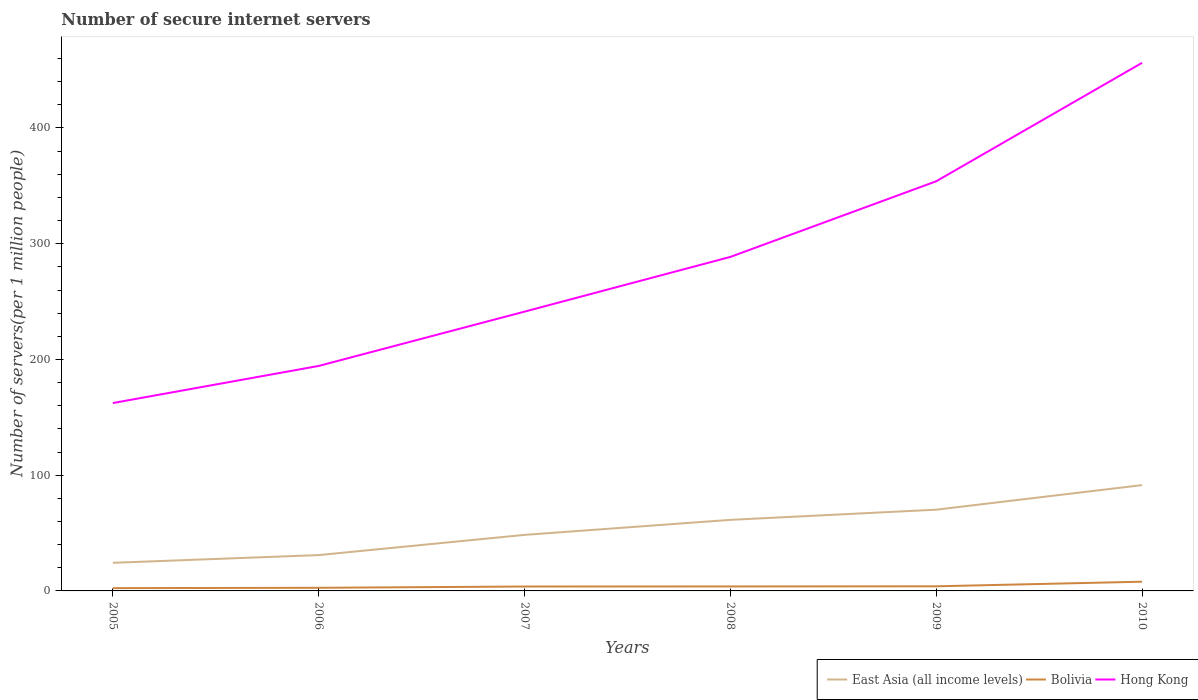Does the line corresponding to Hong Kong intersect with the line corresponding to Bolivia?
Provide a short and direct response. No. Is the number of lines equal to the number of legend labels?
Offer a very short reply. Yes. Across all years, what is the maximum number of secure internet servers in East Asia (all income levels)?
Give a very brief answer. 24.29. What is the total number of secure internet servers in East Asia (all income levels) in the graph?
Ensure brevity in your answer.  -6.67. What is the difference between the highest and the second highest number of secure internet servers in Hong Kong?
Keep it short and to the point. 293.95. What is the difference between two consecutive major ticks on the Y-axis?
Keep it short and to the point. 100. Are the values on the major ticks of Y-axis written in scientific E-notation?
Offer a very short reply. No. Does the graph contain grids?
Keep it short and to the point. No. Where does the legend appear in the graph?
Offer a terse response. Bottom right. What is the title of the graph?
Keep it short and to the point. Number of secure internet servers. What is the label or title of the Y-axis?
Offer a very short reply. Number of servers(per 1 million people). What is the Number of servers(per 1 million people) in East Asia (all income levels) in 2005?
Your answer should be compact. 24.29. What is the Number of servers(per 1 million people) in Bolivia in 2005?
Provide a short and direct response. 2.41. What is the Number of servers(per 1 million people) in Hong Kong in 2005?
Offer a terse response. 162.33. What is the Number of servers(per 1 million people) of East Asia (all income levels) in 2006?
Your answer should be compact. 30.96. What is the Number of servers(per 1 million people) in Bolivia in 2006?
Offer a very short reply. 2.69. What is the Number of servers(per 1 million people) of Hong Kong in 2006?
Keep it short and to the point. 194.4. What is the Number of servers(per 1 million people) of East Asia (all income levels) in 2007?
Keep it short and to the point. 48.42. What is the Number of servers(per 1 million people) of Bolivia in 2007?
Offer a very short reply. 3.81. What is the Number of servers(per 1 million people) of Hong Kong in 2007?
Keep it short and to the point. 241.31. What is the Number of servers(per 1 million people) of East Asia (all income levels) in 2008?
Your response must be concise. 61.4. What is the Number of servers(per 1 million people) in Bolivia in 2008?
Offer a very short reply. 3.85. What is the Number of servers(per 1 million people) of Hong Kong in 2008?
Provide a short and direct response. 288.6. What is the Number of servers(per 1 million people) in East Asia (all income levels) in 2009?
Give a very brief answer. 70.2. What is the Number of servers(per 1 million people) in Bolivia in 2009?
Provide a succinct answer. 4. What is the Number of servers(per 1 million people) in Hong Kong in 2009?
Offer a very short reply. 353.95. What is the Number of servers(per 1 million people) of East Asia (all income levels) in 2010?
Provide a succinct answer. 91.42. What is the Number of servers(per 1 million people) of Bolivia in 2010?
Ensure brevity in your answer.  7.97. What is the Number of servers(per 1 million people) in Hong Kong in 2010?
Your answer should be very brief. 456.28. Across all years, what is the maximum Number of servers(per 1 million people) of East Asia (all income levels)?
Give a very brief answer. 91.42. Across all years, what is the maximum Number of servers(per 1 million people) in Bolivia?
Your answer should be compact. 7.97. Across all years, what is the maximum Number of servers(per 1 million people) of Hong Kong?
Offer a terse response. 456.28. Across all years, what is the minimum Number of servers(per 1 million people) in East Asia (all income levels)?
Offer a very short reply. 24.29. Across all years, what is the minimum Number of servers(per 1 million people) in Bolivia?
Your response must be concise. 2.41. Across all years, what is the minimum Number of servers(per 1 million people) in Hong Kong?
Keep it short and to the point. 162.33. What is the total Number of servers(per 1 million people) of East Asia (all income levels) in the graph?
Give a very brief answer. 326.7. What is the total Number of servers(per 1 million people) in Bolivia in the graph?
Give a very brief answer. 24.73. What is the total Number of servers(per 1 million people) of Hong Kong in the graph?
Your response must be concise. 1696.87. What is the difference between the Number of servers(per 1 million people) of East Asia (all income levels) in 2005 and that in 2006?
Make the answer very short. -6.67. What is the difference between the Number of servers(per 1 million people) of Bolivia in 2005 and that in 2006?
Your answer should be very brief. -0.28. What is the difference between the Number of servers(per 1 million people) in Hong Kong in 2005 and that in 2006?
Offer a very short reply. -32.07. What is the difference between the Number of servers(per 1 million people) in East Asia (all income levels) in 2005 and that in 2007?
Ensure brevity in your answer.  -24.13. What is the difference between the Number of servers(per 1 million people) of Bolivia in 2005 and that in 2007?
Offer a very short reply. -1.4. What is the difference between the Number of servers(per 1 million people) in Hong Kong in 2005 and that in 2007?
Your response must be concise. -78.98. What is the difference between the Number of servers(per 1 million people) of East Asia (all income levels) in 2005 and that in 2008?
Your answer should be compact. -37.11. What is the difference between the Number of servers(per 1 million people) in Bolivia in 2005 and that in 2008?
Give a very brief answer. -1.44. What is the difference between the Number of servers(per 1 million people) in Hong Kong in 2005 and that in 2008?
Provide a succinct answer. -126.27. What is the difference between the Number of servers(per 1 million people) in East Asia (all income levels) in 2005 and that in 2009?
Keep it short and to the point. -45.91. What is the difference between the Number of servers(per 1 million people) of Bolivia in 2005 and that in 2009?
Your response must be concise. -1.59. What is the difference between the Number of servers(per 1 million people) in Hong Kong in 2005 and that in 2009?
Ensure brevity in your answer.  -191.61. What is the difference between the Number of servers(per 1 million people) of East Asia (all income levels) in 2005 and that in 2010?
Provide a succinct answer. -67.13. What is the difference between the Number of servers(per 1 million people) of Bolivia in 2005 and that in 2010?
Your answer should be compact. -5.55. What is the difference between the Number of servers(per 1 million people) in Hong Kong in 2005 and that in 2010?
Make the answer very short. -293.95. What is the difference between the Number of servers(per 1 million people) of East Asia (all income levels) in 2006 and that in 2007?
Your response must be concise. -17.46. What is the difference between the Number of servers(per 1 million people) in Bolivia in 2006 and that in 2007?
Offer a very short reply. -1.12. What is the difference between the Number of servers(per 1 million people) of Hong Kong in 2006 and that in 2007?
Your answer should be compact. -46.92. What is the difference between the Number of servers(per 1 million people) in East Asia (all income levels) in 2006 and that in 2008?
Your answer should be compact. -30.44. What is the difference between the Number of servers(per 1 million people) in Bolivia in 2006 and that in 2008?
Make the answer very short. -1.16. What is the difference between the Number of servers(per 1 million people) in Hong Kong in 2006 and that in 2008?
Offer a terse response. -94.2. What is the difference between the Number of servers(per 1 million people) in East Asia (all income levels) in 2006 and that in 2009?
Provide a short and direct response. -39.24. What is the difference between the Number of servers(per 1 million people) in Bolivia in 2006 and that in 2009?
Offer a very short reply. -1.3. What is the difference between the Number of servers(per 1 million people) in Hong Kong in 2006 and that in 2009?
Provide a short and direct response. -159.55. What is the difference between the Number of servers(per 1 million people) in East Asia (all income levels) in 2006 and that in 2010?
Ensure brevity in your answer.  -60.46. What is the difference between the Number of servers(per 1 million people) of Bolivia in 2006 and that in 2010?
Your answer should be very brief. -5.27. What is the difference between the Number of servers(per 1 million people) of Hong Kong in 2006 and that in 2010?
Ensure brevity in your answer.  -261.88. What is the difference between the Number of servers(per 1 million people) in East Asia (all income levels) in 2007 and that in 2008?
Ensure brevity in your answer.  -12.98. What is the difference between the Number of servers(per 1 million people) of Bolivia in 2007 and that in 2008?
Provide a succinct answer. -0.04. What is the difference between the Number of servers(per 1 million people) in Hong Kong in 2007 and that in 2008?
Make the answer very short. -47.28. What is the difference between the Number of servers(per 1 million people) of East Asia (all income levels) in 2007 and that in 2009?
Make the answer very short. -21.78. What is the difference between the Number of servers(per 1 million people) in Bolivia in 2007 and that in 2009?
Your response must be concise. -0.18. What is the difference between the Number of servers(per 1 million people) in Hong Kong in 2007 and that in 2009?
Keep it short and to the point. -112.63. What is the difference between the Number of servers(per 1 million people) in East Asia (all income levels) in 2007 and that in 2010?
Keep it short and to the point. -43.01. What is the difference between the Number of servers(per 1 million people) in Bolivia in 2007 and that in 2010?
Give a very brief answer. -4.15. What is the difference between the Number of servers(per 1 million people) in Hong Kong in 2007 and that in 2010?
Your response must be concise. -214.97. What is the difference between the Number of servers(per 1 million people) of East Asia (all income levels) in 2008 and that in 2009?
Provide a succinct answer. -8.8. What is the difference between the Number of servers(per 1 million people) of Bolivia in 2008 and that in 2009?
Provide a succinct answer. -0.14. What is the difference between the Number of servers(per 1 million people) in Hong Kong in 2008 and that in 2009?
Your response must be concise. -65.35. What is the difference between the Number of servers(per 1 million people) in East Asia (all income levels) in 2008 and that in 2010?
Your response must be concise. -30.02. What is the difference between the Number of servers(per 1 million people) of Bolivia in 2008 and that in 2010?
Offer a very short reply. -4.11. What is the difference between the Number of servers(per 1 million people) in Hong Kong in 2008 and that in 2010?
Your answer should be compact. -167.68. What is the difference between the Number of servers(per 1 million people) of East Asia (all income levels) in 2009 and that in 2010?
Offer a terse response. -21.22. What is the difference between the Number of servers(per 1 million people) of Bolivia in 2009 and that in 2010?
Give a very brief answer. -3.97. What is the difference between the Number of servers(per 1 million people) in Hong Kong in 2009 and that in 2010?
Your response must be concise. -102.33. What is the difference between the Number of servers(per 1 million people) of East Asia (all income levels) in 2005 and the Number of servers(per 1 million people) of Bolivia in 2006?
Offer a very short reply. 21.6. What is the difference between the Number of servers(per 1 million people) in East Asia (all income levels) in 2005 and the Number of servers(per 1 million people) in Hong Kong in 2006?
Offer a very short reply. -170.11. What is the difference between the Number of servers(per 1 million people) in Bolivia in 2005 and the Number of servers(per 1 million people) in Hong Kong in 2006?
Provide a short and direct response. -191.99. What is the difference between the Number of servers(per 1 million people) in East Asia (all income levels) in 2005 and the Number of servers(per 1 million people) in Bolivia in 2007?
Provide a short and direct response. 20.48. What is the difference between the Number of servers(per 1 million people) of East Asia (all income levels) in 2005 and the Number of servers(per 1 million people) of Hong Kong in 2007?
Provide a short and direct response. -217.02. What is the difference between the Number of servers(per 1 million people) of Bolivia in 2005 and the Number of servers(per 1 million people) of Hong Kong in 2007?
Ensure brevity in your answer.  -238.9. What is the difference between the Number of servers(per 1 million people) of East Asia (all income levels) in 2005 and the Number of servers(per 1 million people) of Bolivia in 2008?
Offer a very short reply. 20.44. What is the difference between the Number of servers(per 1 million people) of East Asia (all income levels) in 2005 and the Number of servers(per 1 million people) of Hong Kong in 2008?
Provide a short and direct response. -264.31. What is the difference between the Number of servers(per 1 million people) of Bolivia in 2005 and the Number of servers(per 1 million people) of Hong Kong in 2008?
Your answer should be very brief. -286.19. What is the difference between the Number of servers(per 1 million people) of East Asia (all income levels) in 2005 and the Number of servers(per 1 million people) of Bolivia in 2009?
Offer a very short reply. 20.29. What is the difference between the Number of servers(per 1 million people) of East Asia (all income levels) in 2005 and the Number of servers(per 1 million people) of Hong Kong in 2009?
Your answer should be compact. -329.66. What is the difference between the Number of servers(per 1 million people) of Bolivia in 2005 and the Number of servers(per 1 million people) of Hong Kong in 2009?
Your answer should be very brief. -351.54. What is the difference between the Number of servers(per 1 million people) of East Asia (all income levels) in 2005 and the Number of servers(per 1 million people) of Bolivia in 2010?
Give a very brief answer. 16.33. What is the difference between the Number of servers(per 1 million people) of East Asia (all income levels) in 2005 and the Number of servers(per 1 million people) of Hong Kong in 2010?
Your answer should be very brief. -431.99. What is the difference between the Number of servers(per 1 million people) in Bolivia in 2005 and the Number of servers(per 1 million people) in Hong Kong in 2010?
Offer a terse response. -453.87. What is the difference between the Number of servers(per 1 million people) in East Asia (all income levels) in 2006 and the Number of servers(per 1 million people) in Bolivia in 2007?
Provide a short and direct response. 27.15. What is the difference between the Number of servers(per 1 million people) in East Asia (all income levels) in 2006 and the Number of servers(per 1 million people) in Hong Kong in 2007?
Ensure brevity in your answer.  -210.35. What is the difference between the Number of servers(per 1 million people) in Bolivia in 2006 and the Number of servers(per 1 million people) in Hong Kong in 2007?
Provide a short and direct response. -238.62. What is the difference between the Number of servers(per 1 million people) in East Asia (all income levels) in 2006 and the Number of servers(per 1 million people) in Bolivia in 2008?
Ensure brevity in your answer.  27.11. What is the difference between the Number of servers(per 1 million people) in East Asia (all income levels) in 2006 and the Number of servers(per 1 million people) in Hong Kong in 2008?
Your answer should be compact. -257.63. What is the difference between the Number of servers(per 1 million people) of Bolivia in 2006 and the Number of servers(per 1 million people) of Hong Kong in 2008?
Provide a short and direct response. -285.9. What is the difference between the Number of servers(per 1 million people) in East Asia (all income levels) in 2006 and the Number of servers(per 1 million people) in Bolivia in 2009?
Offer a terse response. 26.97. What is the difference between the Number of servers(per 1 million people) of East Asia (all income levels) in 2006 and the Number of servers(per 1 million people) of Hong Kong in 2009?
Offer a very short reply. -322.98. What is the difference between the Number of servers(per 1 million people) in Bolivia in 2006 and the Number of servers(per 1 million people) in Hong Kong in 2009?
Your answer should be compact. -351.25. What is the difference between the Number of servers(per 1 million people) in East Asia (all income levels) in 2006 and the Number of servers(per 1 million people) in Bolivia in 2010?
Your answer should be very brief. 23. What is the difference between the Number of servers(per 1 million people) of East Asia (all income levels) in 2006 and the Number of servers(per 1 million people) of Hong Kong in 2010?
Ensure brevity in your answer.  -425.32. What is the difference between the Number of servers(per 1 million people) in Bolivia in 2006 and the Number of servers(per 1 million people) in Hong Kong in 2010?
Keep it short and to the point. -453.59. What is the difference between the Number of servers(per 1 million people) in East Asia (all income levels) in 2007 and the Number of servers(per 1 million people) in Bolivia in 2008?
Your answer should be compact. 44.56. What is the difference between the Number of servers(per 1 million people) in East Asia (all income levels) in 2007 and the Number of servers(per 1 million people) in Hong Kong in 2008?
Your response must be concise. -240.18. What is the difference between the Number of servers(per 1 million people) in Bolivia in 2007 and the Number of servers(per 1 million people) in Hong Kong in 2008?
Ensure brevity in your answer.  -284.78. What is the difference between the Number of servers(per 1 million people) in East Asia (all income levels) in 2007 and the Number of servers(per 1 million people) in Bolivia in 2009?
Your answer should be compact. 44.42. What is the difference between the Number of servers(per 1 million people) of East Asia (all income levels) in 2007 and the Number of servers(per 1 million people) of Hong Kong in 2009?
Offer a very short reply. -305.53. What is the difference between the Number of servers(per 1 million people) in Bolivia in 2007 and the Number of servers(per 1 million people) in Hong Kong in 2009?
Make the answer very short. -350.13. What is the difference between the Number of servers(per 1 million people) of East Asia (all income levels) in 2007 and the Number of servers(per 1 million people) of Bolivia in 2010?
Your answer should be very brief. 40.45. What is the difference between the Number of servers(per 1 million people) in East Asia (all income levels) in 2007 and the Number of servers(per 1 million people) in Hong Kong in 2010?
Make the answer very short. -407.86. What is the difference between the Number of servers(per 1 million people) in Bolivia in 2007 and the Number of servers(per 1 million people) in Hong Kong in 2010?
Offer a very short reply. -452.47. What is the difference between the Number of servers(per 1 million people) in East Asia (all income levels) in 2008 and the Number of servers(per 1 million people) in Bolivia in 2009?
Provide a succinct answer. 57.4. What is the difference between the Number of servers(per 1 million people) of East Asia (all income levels) in 2008 and the Number of servers(per 1 million people) of Hong Kong in 2009?
Keep it short and to the point. -292.55. What is the difference between the Number of servers(per 1 million people) of Bolivia in 2008 and the Number of servers(per 1 million people) of Hong Kong in 2009?
Offer a very short reply. -350.09. What is the difference between the Number of servers(per 1 million people) of East Asia (all income levels) in 2008 and the Number of servers(per 1 million people) of Bolivia in 2010?
Give a very brief answer. 53.43. What is the difference between the Number of servers(per 1 million people) in East Asia (all income levels) in 2008 and the Number of servers(per 1 million people) in Hong Kong in 2010?
Give a very brief answer. -394.88. What is the difference between the Number of servers(per 1 million people) of Bolivia in 2008 and the Number of servers(per 1 million people) of Hong Kong in 2010?
Make the answer very short. -452.43. What is the difference between the Number of servers(per 1 million people) of East Asia (all income levels) in 2009 and the Number of servers(per 1 million people) of Bolivia in 2010?
Your answer should be very brief. 62.24. What is the difference between the Number of servers(per 1 million people) of East Asia (all income levels) in 2009 and the Number of servers(per 1 million people) of Hong Kong in 2010?
Make the answer very short. -386.08. What is the difference between the Number of servers(per 1 million people) in Bolivia in 2009 and the Number of servers(per 1 million people) in Hong Kong in 2010?
Keep it short and to the point. -452.28. What is the average Number of servers(per 1 million people) in East Asia (all income levels) per year?
Your response must be concise. 54.45. What is the average Number of servers(per 1 million people) in Bolivia per year?
Your response must be concise. 4.12. What is the average Number of servers(per 1 million people) in Hong Kong per year?
Your response must be concise. 282.81. In the year 2005, what is the difference between the Number of servers(per 1 million people) of East Asia (all income levels) and Number of servers(per 1 million people) of Bolivia?
Offer a terse response. 21.88. In the year 2005, what is the difference between the Number of servers(per 1 million people) in East Asia (all income levels) and Number of servers(per 1 million people) in Hong Kong?
Your answer should be very brief. -138.04. In the year 2005, what is the difference between the Number of servers(per 1 million people) in Bolivia and Number of servers(per 1 million people) in Hong Kong?
Keep it short and to the point. -159.92. In the year 2006, what is the difference between the Number of servers(per 1 million people) in East Asia (all income levels) and Number of servers(per 1 million people) in Bolivia?
Offer a terse response. 28.27. In the year 2006, what is the difference between the Number of servers(per 1 million people) in East Asia (all income levels) and Number of servers(per 1 million people) in Hong Kong?
Ensure brevity in your answer.  -163.43. In the year 2006, what is the difference between the Number of servers(per 1 million people) of Bolivia and Number of servers(per 1 million people) of Hong Kong?
Offer a very short reply. -191.7. In the year 2007, what is the difference between the Number of servers(per 1 million people) of East Asia (all income levels) and Number of servers(per 1 million people) of Bolivia?
Your answer should be very brief. 44.61. In the year 2007, what is the difference between the Number of servers(per 1 million people) in East Asia (all income levels) and Number of servers(per 1 million people) in Hong Kong?
Provide a short and direct response. -192.89. In the year 2007, what is the difference between the Number of servers(per 1 million people) in Bolivia and Number of servers(per 1 million people) in Hong Kong?
Your answer should be compact. -237.5. In the year 2008, what is the difference between the Number of servers(per 1 million people) of East Asia (all income levels) and Number of servers(per 1 million people) of Bolivia?
Your answer should be very brief. 57.55. In the year 2008, what is the difference between the Number of servers(per 1 million people) of East Asia (all income levels) and Number of servers(per 1 million people) of Hong Kong?
Offer a terse response. -227.2. In the year 2008, what is the difference between the Number of servers(per 1 million people) in Bolivia and Number of servers(per 1 million people) in Hong Kong?
Make the answer very short. -284.74. In the year 2009, what is the difference between the Number of servers(per 1 million people) of East Asia (all income levels) and Number of servers(per 1 million people) of Bolivia?
Offer a very short reply. 66.2. In the year 2009, what is the difference between the Number of servers(per 1 million people) in East Asia (all income levels) and Number of servers(per 1 million people) in Hong Kong?
Offer a very short reply. -283.75. In the year 2009, what is the difference between the Number of servers(per 1 million people) in Bolivia and Number of servers(per 1 million people) in Hong Kong?
Give a very brief answer. -349.95. In the year 2010, what is the difference between the Number of servers(per 1 million people) of East Asia (all income levels) and Number of servers(per 1 million people) of Bolivia?
Ensure brevity in your answer.  83.46. In the year 2010, what is the difference between the Number of servers(per 1 million people) of East Asia (all income levels) and Number of servers(per 1 million people) of Hong Kong?
Offer a very short reply. -364.86. In the year 2010, what is the difference between the Number of servers(per 1 million people) in Bolivia and Number of servers(per 1 million people) in Hong Kong?
Keep it short and to the point. -448.31. What is the ratio of the Number of servers(per 1 million people) in East Asia (all income levels) in 2005 to that in 2006?
Offer a very short reply. 0.78. What is the ratio of the Number of servers(per 1 million people) of Bolivia in 2005 to that in 2006?
Offer a very short reply. 0.9. What is the ratio of the Number of servers(per 1 million people) of Hong Kong in 2005 to that in 2006?
Give a very brief answer. 0.84. What is the ratio of the Number of servers(per 1 million people) of East Asia (all income levels) in 2005 to that in 2007?
Make the answer very short. 0.5. What is the ratio of the Number of servers(per 1 million people) of Bolivia in 2005 to that in 2007?
Your response must be concise. 0.63. What is the ratio of the Number of servers(per 1 million people) of Hong Kong in 2005 to that in 2007?
Provide a short and direct response. 0.67. What is the ratio of the Number of servers(per 1 million people) in East Asia (all income levels) in 2005 to that in 2008?
Your answer should be compact. 0.4. What is the ratio of the Number of servers(per 1 million people) of Bolivia in 2005 to that in 2008?
Ensure brevity in your answer.  0.63. What is the ratio of the Number of servers(per 1 million people) of Hong Kong in 2005 to that in 2008?
Provide a short and direct response. 0.56. What is the ratio of the Number of servers(per 1 million people) in East Asia (all income levels) in 2005 to that in 2009?
Your response must be concise. 0.35. What is the ratio of the Number of servers(per 1 million people) in Bolivia in 2005 to that in 2009?
Make the answer very short. 0.6. What is the ratio of the Number of servers(per 1 million people) in Hong Kong in 2005 to that in 2009?
Your response must be concise. 0.46. What is the ratio of the Number of servers(per 1 million people) in East Asia (all income levels) in 2005 to that in 2010?
Ensure brevity in your answer.  0.27. What is the ratio of the Number of servers(per 1 million people) in Bolivia in 2005 to that in 2010?
Provide a succinct answer. 0.3. What is the ratio of the Number of servers(per 1 million people) of Hong Kong in 2005 to that in 2010?
Keep it short and to the point. 0.36. What is the ratio of the Number of servers(per 1 million people) in East Asia (all income levels) in 2006 to that in 2007?
Keep it short and to the point. 0.64. What is the ratio of the Number of servers(per 1 million people) in Bolivia in 2006 to that in 2007?
Ensure brevity in your answer.  0.71. What is the ratio of the Number of servers(per 1 million people) in Hong Kong in 2006 to that in 2007?
Provide a short and direct response. 0.81. What is the ratio of the Number of servers(per 1 million people) of East Asia (all income levels) in 2006 to that in 2008?
Ensure brevity in your answer.  0.5. What is the ratio of the Number of servers(per 1 million people) of Bolivia in 2006 to that in 2008?
Make the answer very short. 0.7. What is the ratio of the Number of servers(per 1 million people) in Hong Kong in 2006 to that in 2008?
Provide a succinct answer. 0.67. What is the ratio of the Number of servers(per 1 million people) of East Asia (all income levels) in 2006 to that in 2009?
Offer a very short reply. 0.44. What is the ratio of the Number of servers(per 1 million people) in Bolivia in 2006 to that in 2009?
Offer a very short reply. 0.67. What is the ratio of the Number of servers(per 1 million people) in Hong Kong in 2006 to that in 2009?
Provide a succinct answer. 0.55. What is the ratio of the Number of servers(per 1 million people) of East Asia (all income levels) in 2006 to that in 2010?
Provide a succinct answer. 0.34. What is the ratio of the Number of servers(per 1 million people) of Bolivia in 2006 to that in 2010?
Your answer should be very brief. 0.34. What is the ratio of the Number of servers(per 1 million people) of Hong Kong in 2006 to that in 2010?
Offer a terse response. 0.43. What is the ratio of the Number of servers(per 1 million people) of East Asia (all income levels) in 2007 to that in 2008?
Ensure brevity in your answer.  0.79. What is the ratio of the Number of servers(per 1 million people) in Bolivia in 2007 to that in 2008?
Provide a short and direct response. 0.99. What is the ratio of the Number of servers(per 1 million people) in Hong Kong in 2007 to that in 2008?
Give a very brief answer. 0.84. What is the ratio of the Number of servers(per 1 million people) in East Asia (all income levels) in 2007 to that in 2009?
Offer a very short reply. 0.69. What is the ratio of the Number of servers(per 1 million people) in Bolivia in 2007 to that in 2009?
Make the answer very short. 0.95. What is the ratio of the Number of servers(per 1 million people) of Hong Kong in 2007 to that in 2009?
Your answer should be compact. 0.68. What is the ratio of the Number of servers(per 1 million people) in East Asia (all income levels) in 2007 to that in 2010?
Your answer should be compact. 0.53. What is the ratio of the Number of servers(per 1 million people) of Bolivia in 2007 to that in 2010?
Keep it short and to the point. 0.48. What is the ratio of the Number of servers(per 1 million people) in Hong Kong in 2007 to that in 2010?
Keep it short and to the point. 0.53. What is the ratio of the Number of servers(per 1 million people) in East Asia (all income levels) in 2008 to that in 2009?
Your answer should be compact. 0.87. What is the ratio of the Number of servers(per 1 million people) in Bolivia in 2008 to that in 2009?
Provide a short and direct response. 0.96. What is the ratio of the Number of servers(per 1 million people) of Hong Kong in 2008 to that in 2009?
Your response must be concise. 0.82. What is the ratio of the Number of servers(per 1 million people) in East Asia (all income levels) in 2008 to that in 2010?
Offer a terse response. 0.67. What is the ratio of the Number of servers(per 1 million people) of Bolivia in 2008 to that in 2010?
Your answer should be compact. 0.48. What is the ratio of the Number of servers(per 1 million people) of Hong Kong in 2008 to that in 2010?
Your answer should be very brief. 0.63. What is the ratio of the Number of servers(per 1 million people) of East Asia (all income levels) in 2009 to that in 2010?
Provide a short and direct response. 0.77. What is the ratio of the Number of servers(per 1 million people) in Bolivia in 2009 to that in 2010?
Your answer should be compact. 0.5. What is the ratio of the Number of servers(per 1 million people) in Hong Kong in 2009 to that in 2010?
Offer a terse response. 0.78. What is the difference between the highest and the second highest Number of servers(per 1 million people) in East Asia (all income levels)?
Offer a terse response. 21.22. What is the difference between the highest and the second highest Number of servers(per 1 million people) of Bolivia?
Your answer should be compact. 3.97. What is the difference between the highest and the second highest Number of servers(per 1 million people) of Hong Kong?
Give a very brief answer. 102.33. What is the difference between the highest and the lowest Number of servers(per 1 million people) of East Asia (all income levels)?
Give a very brief answer. 67.13. What is the difference between the highest and the lowest Number of servers(per 1 million people) of Bolivia?
Your response must be concise. 5.55. What is the difference between the highest and the lowest Number of servers(per 1 million people) of Hong Kong?
Ensure brevity in your answer.  293.95. 